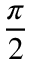<formula> <loc_0><loc_0><loc_500><loc_500>\frac { \pi } { 2 }</formula> 